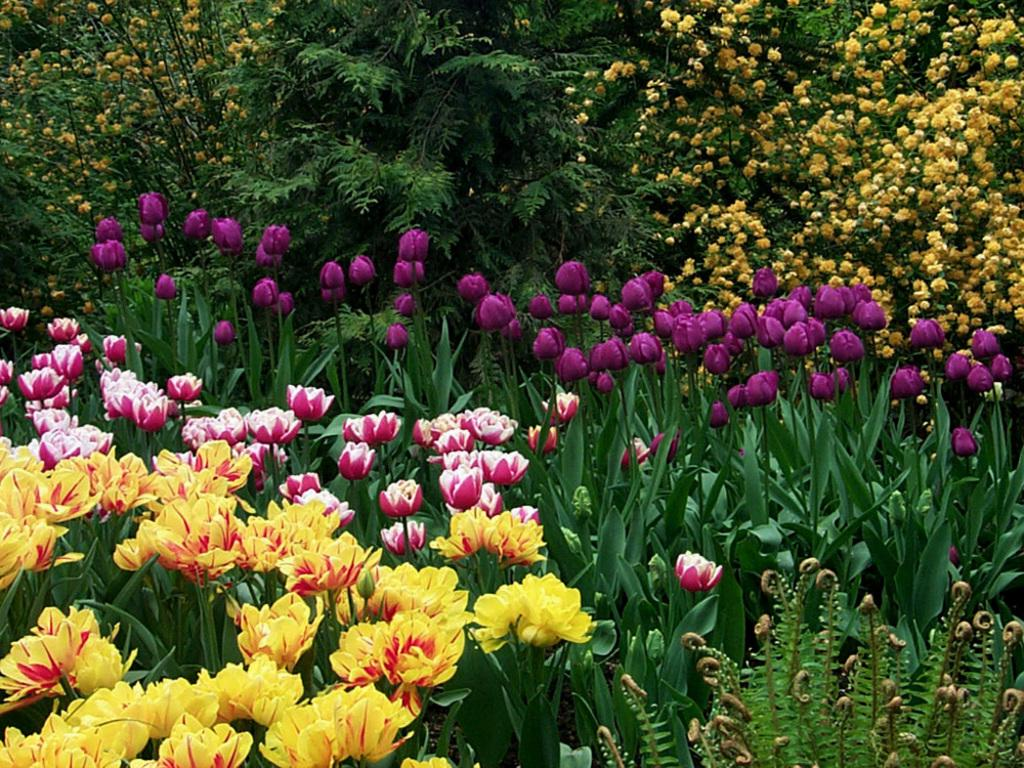What type of plants can be seen in the image? There are flower plants in the image. What type of carriage is being pulled by the feather in the image? There is no carriage or feather present in the image; it only features flower plants. 